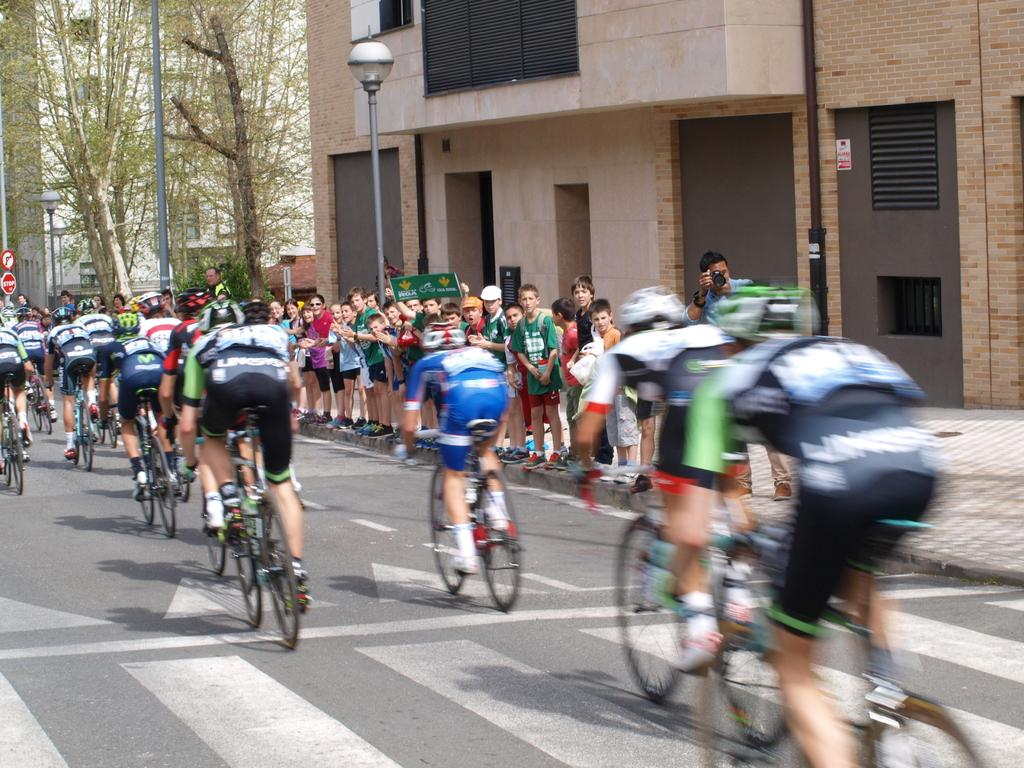What are the people in the image doing? The people in the image are sitting on bicycles. Are there any other people in the image? Yes, there are people standing on a footpath in the image. What can be seen in the background of the image? There are a lot of trees in the image. What type of care can be seen being provided to the lizards in the image? There are no lizards present in the image, so no care can be observed. Is there any sleet visible in the image? There is no sleet present in the image; it appears to be a clear day with trees in the background. 